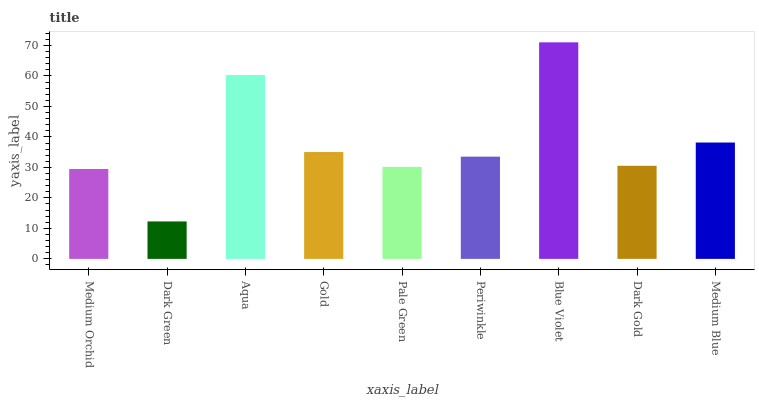Is Dark Green the minimum?
Answer yes or no. Yes. Is Blue Violet the maximum?
Answer yes or no. Yes. Is Aqua the minimum?
Answer yes or no. No. Is Aqua the maximum?
Answer yes or no. No. Is Aqua greater than Dark Green?
Answer yes or no. Yes. Is Dark Green less than Aqua?
Answer yes or no. Yes. Is Dark Green greater than Aqua?
Answer yes or no. No. Is Aqua less than Dark Green?
Answer yes or no. No. Is Periwinkle the high median?
Answer yes or no. Yes. Is Periwinkle the low median?
Answer yes or no. Yes. Is Medium Orchid the high median?
Answer yes or no. No. Is Dark Gold the low median?
Answer yes or no. No. 